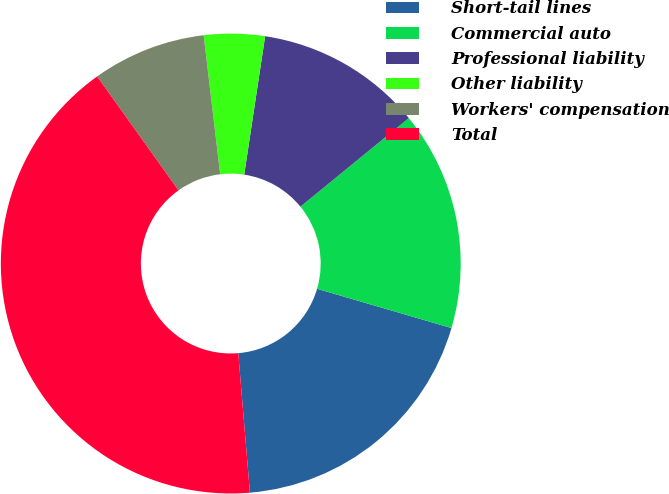Convert chart to OTSL. <chart><loc_0><loc_0><loc_500><loc_500><pie_chart><fcel>Short-tail lines<fcel>Commercial auto<fcel>Professional liability<fcel>Other liability<fcel>Workers' compensation<fcel>Total<nl><fcel>19.15%<fcel>15.43%<fcel>11.71%<fcel>4.27%<fcel>7.99%<fcel>41.46%<nl></chart> 